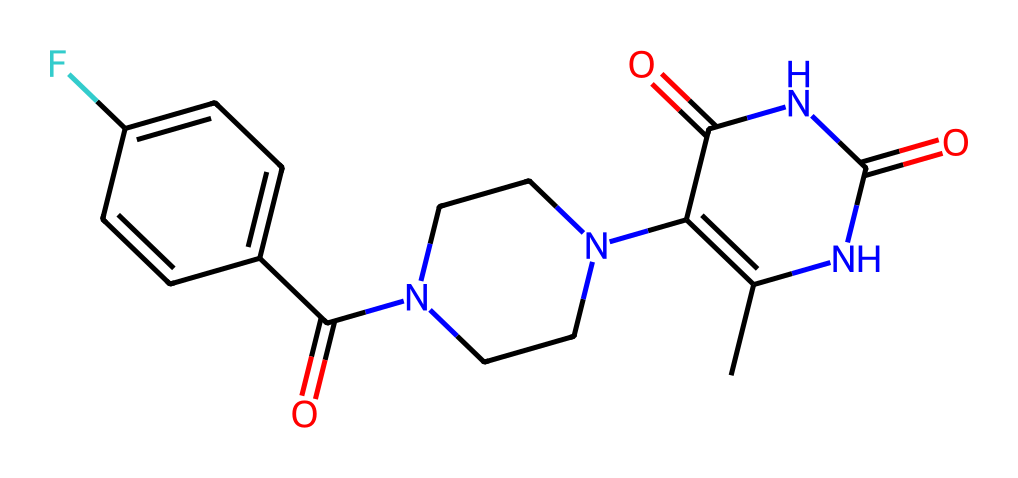What is the molecular formula of this compound? To derive the molecular formula, we count the number of each type of atom in the SMILES representation. The SMILES indicates the presence of 15 carbons (C), 19 hydrogens (H), 3 nitrogens (N), 3 oxygens (O), and 1 fluorine (F). Therefore, the molecular formula becomes C15H19F3N3O3.
Answer: C15H19F3N3O3 How many carbon atoms are in this molecule? By analyzing the SMILES, we identify 15 instances of carbon (C). Each capital letter corresponds to one atom, hence we count 15 carbon atoms in total.
Answer: 15 What functional groups can be identified in this structure? In the structure, there is an amide (due to the presence of carbonyl followed by nitrogen, -C(=O)N), a ketone (due to the -C(=O)- portion), and a fluorine substituent. Thus, we can say that amide, ketone, and fluorine are present.
Answer: amide, ketone, fluorine What type of isomerism might this compound exhibit? Given the structure includes a ring and various substituents, this compound may exhibit geometric isomerism (cis/trans) and possibly stereoisomerism due to the presence of chirality around the nitrogen atoms. The presence of rings also allows for possible isomer configurations.
Answer: geometric isomerism, stereoisomerism Does this molecule contain any heteroatoms? By examining the SMILES sequence, we find nitrogen (N) and oxygen (O) atoms, both of which are heteroatoms (non-carbon, non-hydrogen). Therefore, this molecule contains heteroatoms in its structure.
Answer: yes 